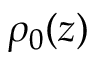Convert formula to latex. <formula><loc_0><loc_0><loc_500><loc_500>\rho _ { 0 } ( z )</formula> 